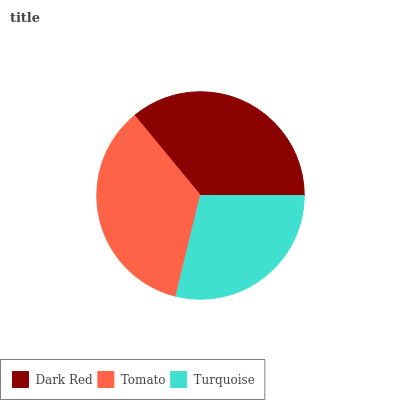Is Turquoise the minimum?
Answer yes or no. Yes. Is Dark Red the maximum?
Answer yes or no. Yes. Is Tomato the minimum?
Answer yes or no. No. Is Tomato the maximum?
Answer yes or no. No. Is Dark Red greater than Tomato?
Answer yes or no. Yes. Is Tomato less than Dark Red?
Answer yes or no. Yes. Is Tomato greater than Dark Red?
Answer yes or no. No. Is Dark Red less than Tomato?
Answer yes or no. No. Is Tomato the high median?
Answer yes or no. Yes. Is Tomato the low median?
Answer yes or no. Yes. Is Turquoise the high median?
Answer yes or no. No. Is Dark Red the low median?
Answer yes or no. No. 